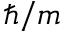<formula> <loc_0><loc_0><loc_500><loc_500>\hbar { / } m</formula> 